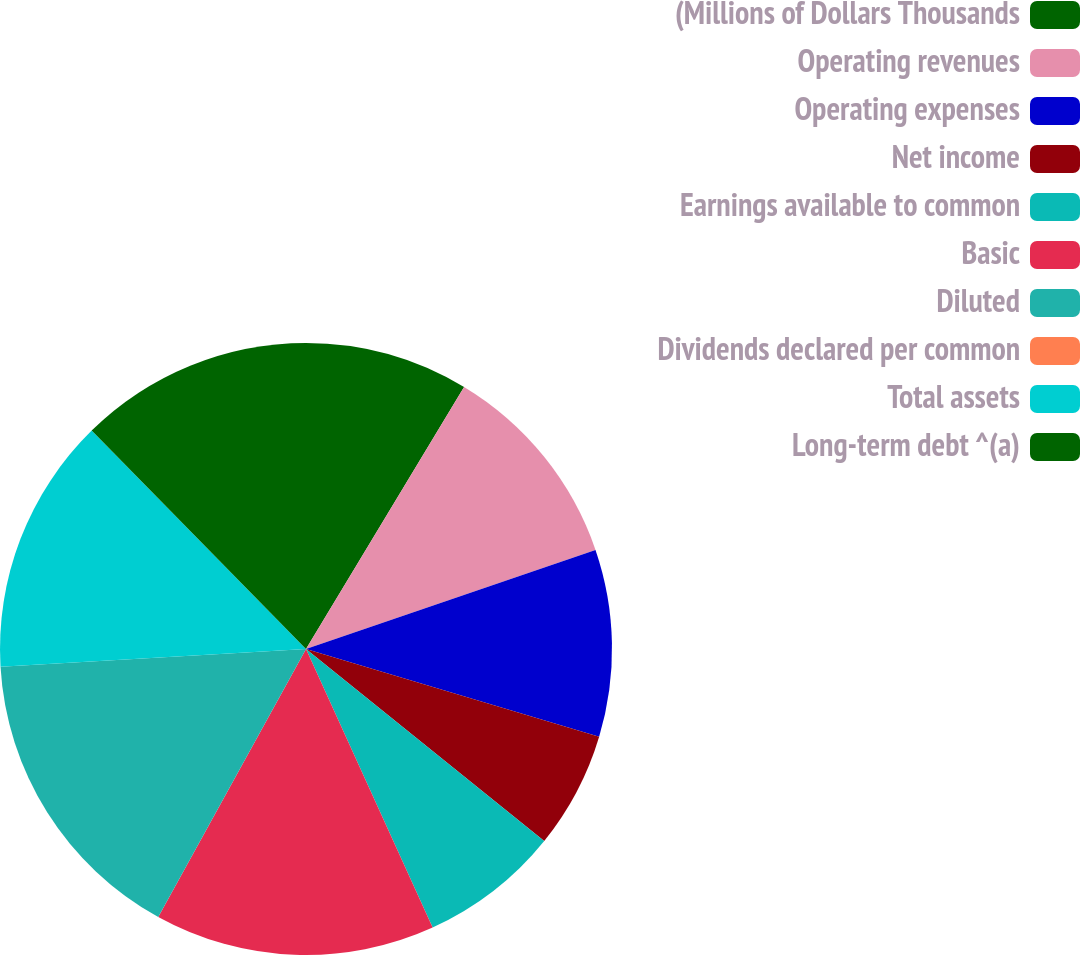Convert chart. <chart><loc_0><loc_0><loc_500><loc_500><pie_chart><fcel>(Millions of Dollars Thousands<fcel>Operating revenues<fcel>Operating expenses<fcel>Net income<fcel>Earnings available to common<fcel>Basic<fcel>Diluted<fcel>Dividends declared per common<fcel>Total assets<fcel>Long-term debt ^(a)<nl><fcel>8.64%<fcel>11.11%<fcel>9.88%<fcel>6.17%<fcel>7.41%<fcel>14.81%<fcel>16.05%<fcel>0.0%<fcel>13.58%<fcel>12.35%<nl></chart> 